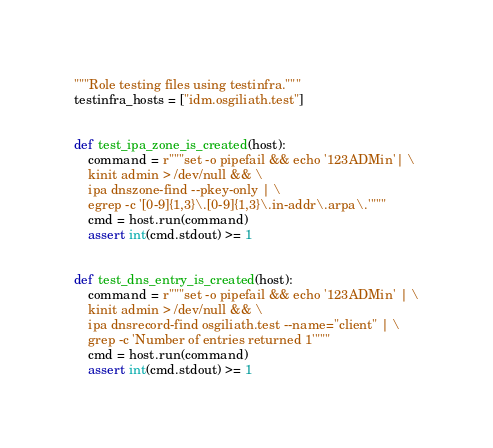<code> <loc_0><loc_0><loc_500><loc_500><_Python_>"""Role testing files using testinfra."""
testinfra_hosts = ["idm.osgiliath.test"]


def test_ipa_zone_is_created(host):
    command = r"""set -o pipefail && echo '123ADMin'| \
    kinit admin > /dev/null && \
    ipa dnszone-find --pkey-only | \
    egrep -c '[0-9]{1,3}\.[0-9]{1,3}\.in-addr\.arpa\.'"""
    cmd = host.run(command)
    assert int(cmd.stdout) >= 1


def test_dns_entry_is_created(host):
    command = r"""set -o pipefail && echo '123ADMin' | \
    kinit admin > /dev/null && \
    ipa dnsrecord-find osgiliath.test --name="client" | \
    grep -c 'Number of entries returned 1'"""
    cmd = host.run(command)
    assert int(cmd.stdout) >= 1
</code> 